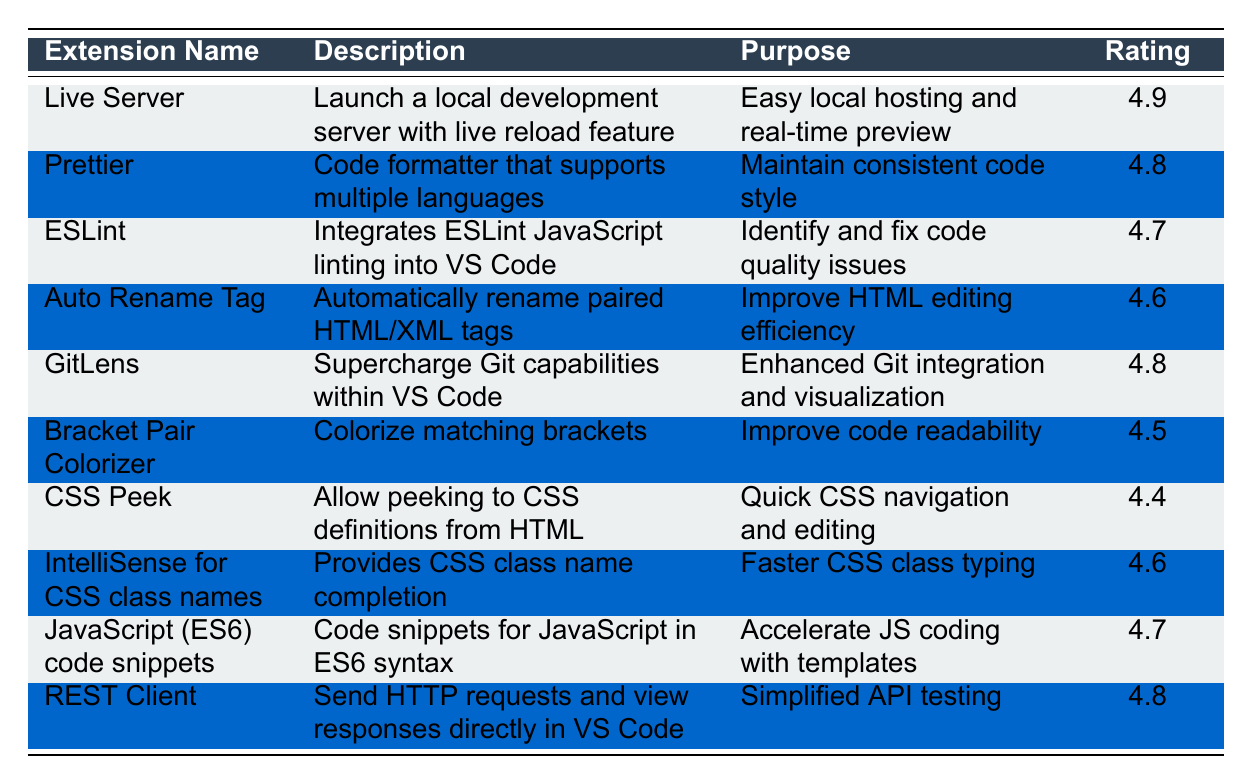What is the rating of the "Live Server" extension? The table shows that the rating for "Live Server" is listed in the Rating column, which indicates it is 4.9.
Answer: 4.9 Which extension has the lowest rating? By comparing the rating values in the table, "CSS Peek" has the lowest rating at 4.4.
Answer: CSS Peek How many extensions have a rating of 4.8 or higher? Reviewing the ratings, five extensions have ratings of 4.8 or above: "Live Server," "Prettier," "GitLens," "REST Client," and "ESLint."
Answer: 5 Is "Bracket Pair Colorizer" rated higher than "Auto Rename Tag"? The rating of "Bracket Pair Colorizer" is 4.5 and "Auto Rename Tag" is rated 4.6. Therefore, "Bracket Pair Colorizer" is not rated higher.
Answer: No What is the average rating of all the extensions listed? To find the average, sum the ratings (4.9 + 4.8 + 4.7 + 4.6 + 4.8 + 4.5 + 4.4 + 4.6 + 4.7 + 4.8 = 47.8) and divide by the number of extensions (10). The average is 47.8 / 10 = 4.78.
Answer: 4.78 Which extension's purpose is to improve HTML editing efficiency? The purpose for "Auto Rename Tag" is explicitly stated in the table as improving HTML editing efficiency.
Answer: Auto Rename Tag Are there more extensions aimed at code quality improvement or design efficiency? "ESLint" (code quality) and "Auto Rename Tag" (design efficiency) serve purposes in their areas. Comparing, there are more aimed at code quality (counting ESLint vs Bracket Pair Colorizer for design).
Answer: Code quality How does the rating of "REST Client" compare to that of "Prettier"? "REST Client" has a rating of 4.8, while "Prettier" has a rating of 4.8 as well. They are equal in rating.
Answer: They are equal Which extension has a purpose focused on simplified API testing? The table indicates that the "REST Client" extension has a purpose of simplified API testing.
Answer: REST Client Which two extensions have the same rating? "Prettier" and "GitLens" both have the same rating of 4.8.
Answer: Prettier and GitLens What is the total of the ratings of all extensions that support CSS? CSS-related extensions are "CSS Peek" (4.4) and "IntelliSense for CSS class names" (4.6). Summing their ratings, 4.4 + 4.6 = 9.0.
Answer: 9.0 